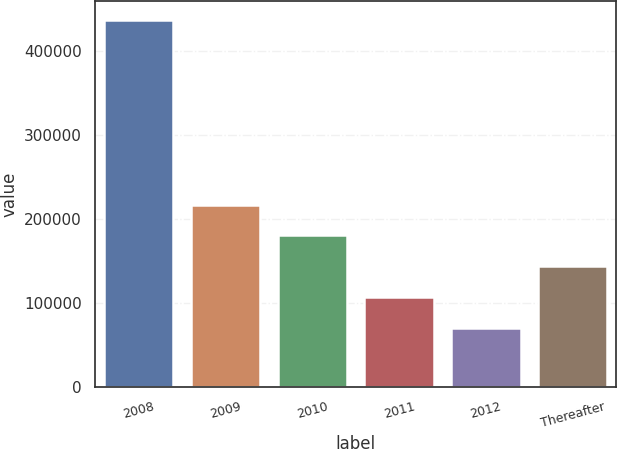<chart> <loc_0><loc_0><loc_500><loc_500><bar_chart><fcel>2008<fcel>2009<fcel>2010<fcel>2011<fcel>2012<fcel>Thereafter<nl><fcel>437027<fcel>217113<fcel>180460<fcel>107155<fcel>70503<fcel>143808<nl></chart> 